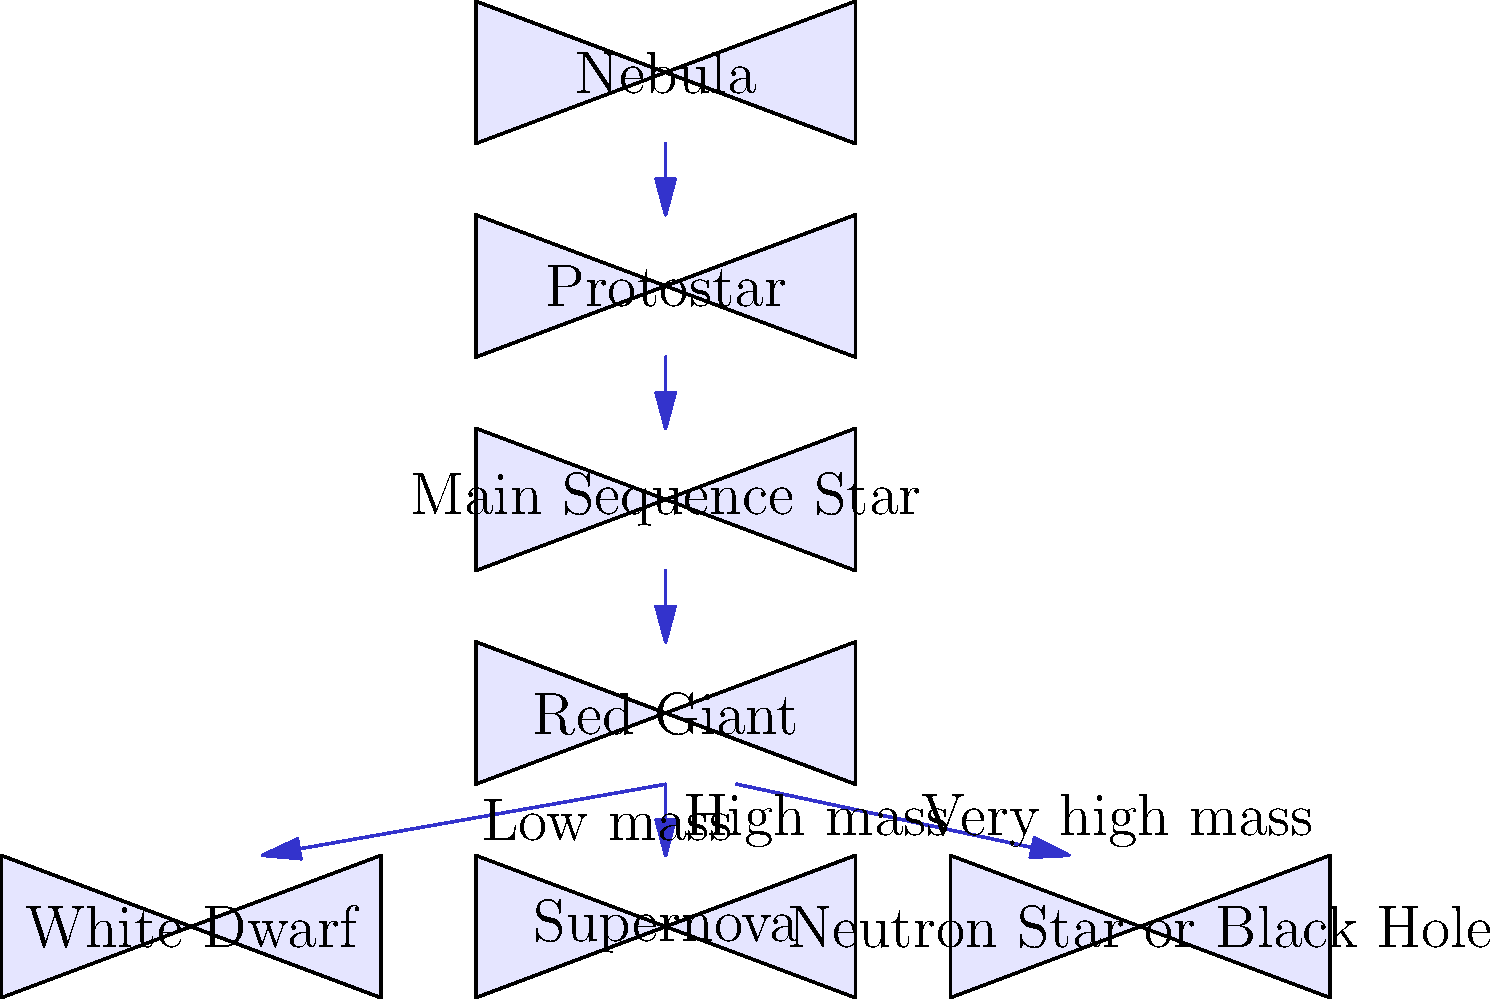As an aspiring healthcare professional interested in the interconnectedness of scientific disciplines, consider the life cycle of a star as shown in the flowchart. At which stage does a star spend the majority of its life, and what process primarily occurs during this phase? To answer this question, let's follow the life cycle of a star step-by-step:

1. The star's life begins as a Nebula, a cloud of gas and dust.
2. As gravity causes the nebula to collapse, it forms a Protostar.
3. The protostar continues to contract and heat up until it reaches the Main Sequence Star stage.
4. The Main Sequence Star is the longest phase in a star's life cycle. This is where the star spends the majority of its lifetime.
5. During the Main Sequence phase, the primary process occurring is nuclear fusion. The star fuses hydrogen into helium in its core, releasing enormous amounts of energy.
6. The duration of the Main Sequence phase depends on the star's mass. Smaller stars burn their fuel more slowly and can remain in this stage for billions of years.
7. After the Main Sequence, the star evolves into a Red Giant.
8. The final stages depend on the star's mass:
   - Low mass stars become White Dwarfs
   - High mass stars undergo a Supernova
   - Very high mass stars may become Neutron Stars or Black Holes

The Main Sequence stage is crucial because it's the most stable and longest-lasting phase in a star's life. Understanding this process is relevant to healthcare as it demonstrates the importance of stable, long-term processes in complex systems, which can be analogous to maintaining homeostasis in the human body.
Answer: Main Sequence; nuclear fusion of hydrogen into helium 